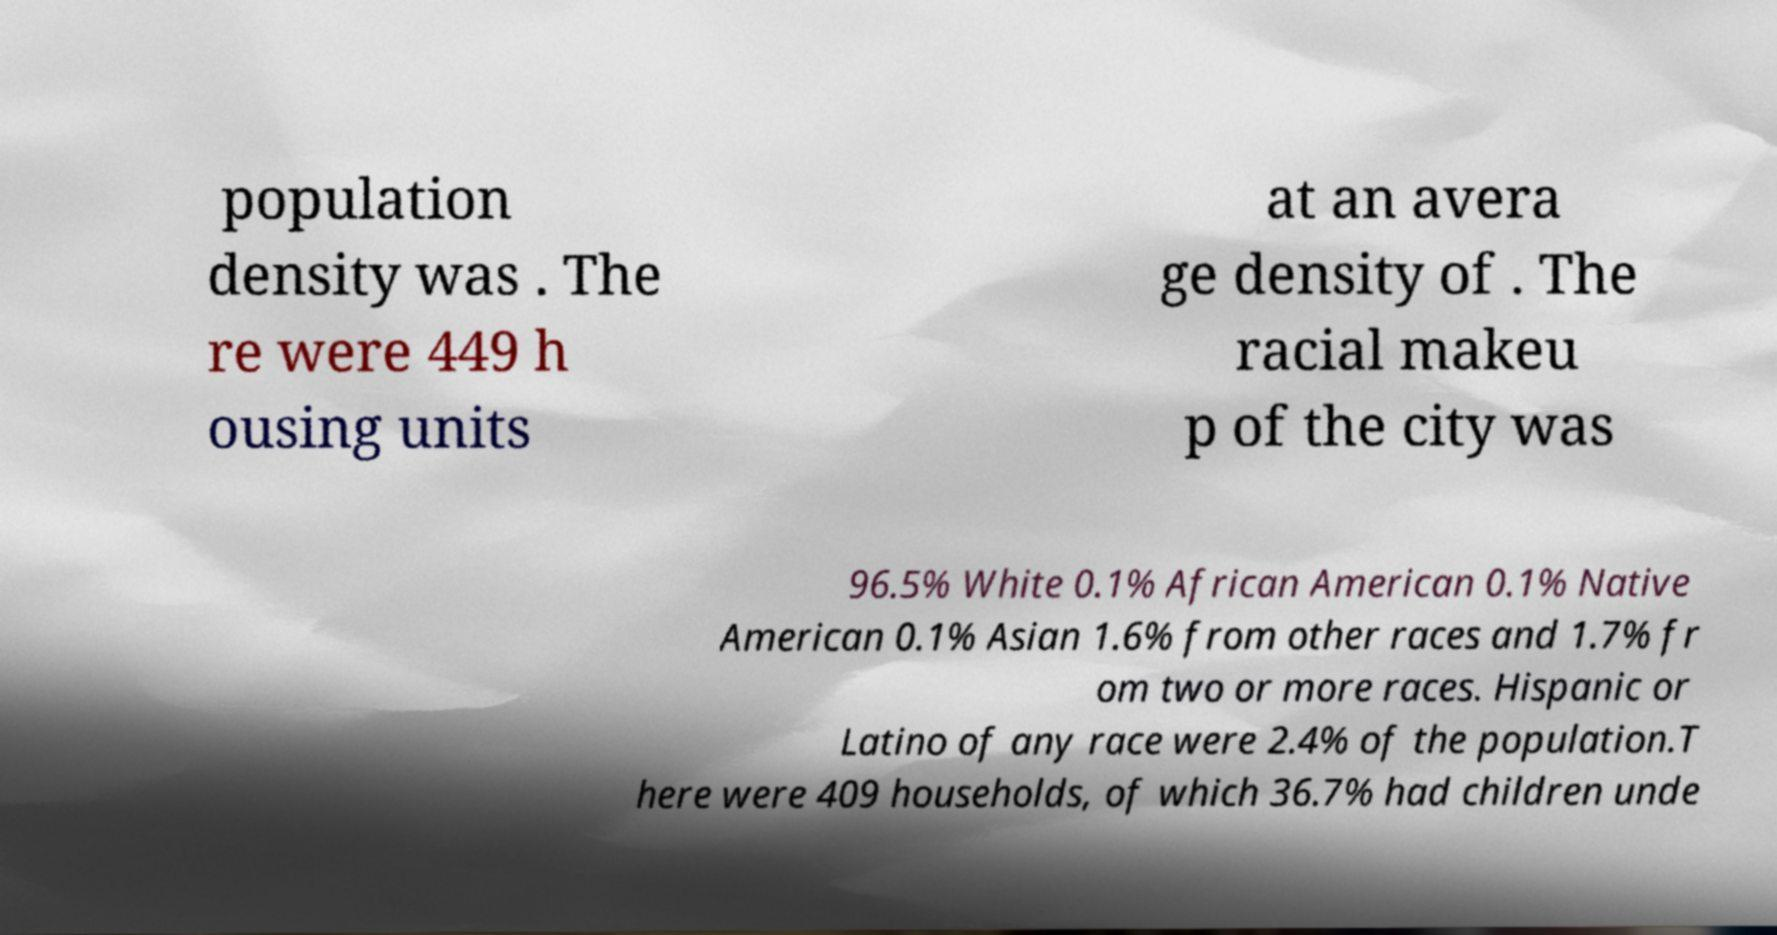There's text embedded in this image that I need extracted. Can you transcribe it verbatim? population density was . The re were 449 h ousing units at an avera ge density of . The racial makeu p of the city was 96.5% White 0.1% African American 0.1% Native American 0.1% Asian 1.6% from other races and 1.7% fr om two or more races. Hispanic or Latino of any race were 2.4% of the population.T here were 409 households, of which 36.7% had children unde 